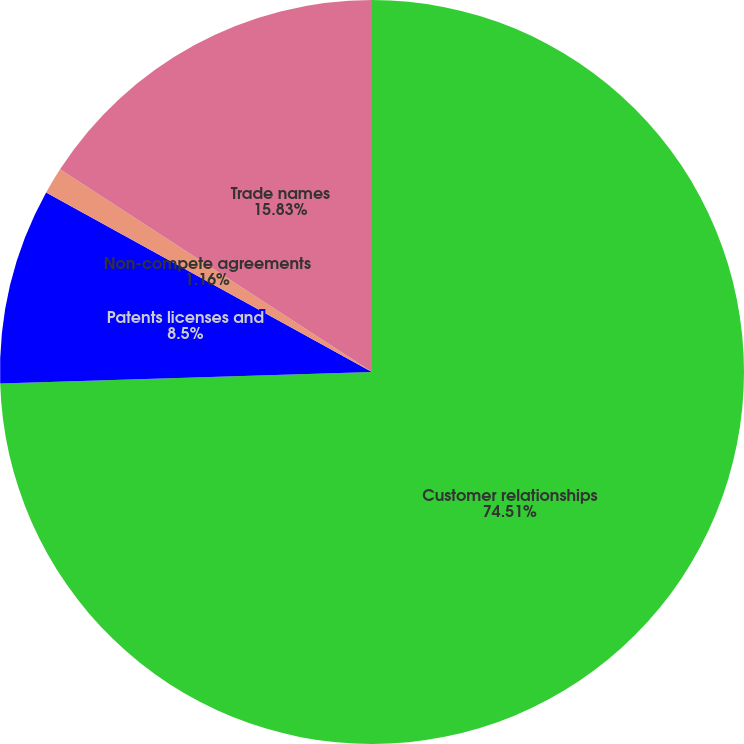Convert chart. <chart><loc_0><loc_0><loc_500><loc_500><pie_chart><fcel>Customer relationships<fcel>Patents licenses and<fcel>Non-compete agreements<fcel>Trade names<nl><fcel>74.51%<fcel>8.5%<fcel>1.16%<fcel>15.83%<nl></chart> 